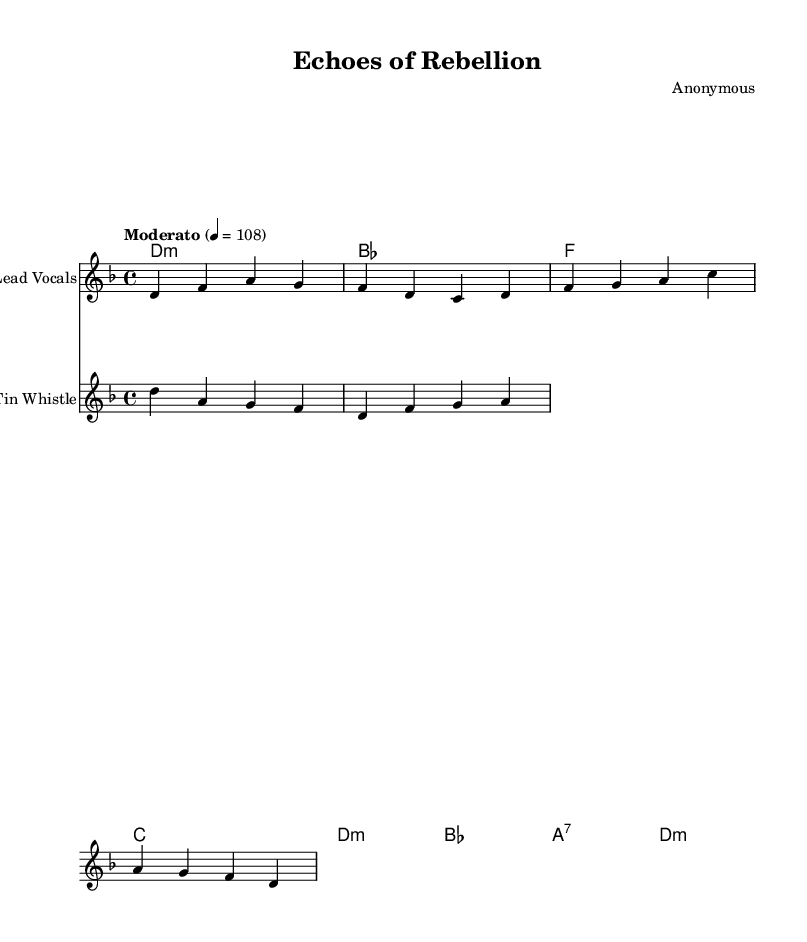What is the key signature of this music? The key signature is D minor, indicated by the presence of one flat (B flat) in the key signature.
Answer: D minor What is the time signature? The time signature is 4/4, which is commonly notated at the beginning of the sheet music.
Answer: 4/4 What is the tempo marking given? The tempo marking is "Moderato," indicating a moderate pace for the music.
Answer: Moderato How many chords are used in the harmonies? There are four distinct chords used in the harmonies: D minor, B flat, F major, and C major, plus a seventh chord in the sequence.
Answer: Four Identify the instrument associated with the second staff. The second staff is associated with the "Tin Whistle," which is indicated by the label provided in the staff description.
Answer: Tin Whistle What phrase is sung in the first verse? The phrase sung in the first verse includes "In the streets of Dublin town." This can be seen underneath the staff that represents the Lead Vocals.
Answer: In the streets of Dublin town What is the first note of the melody in the lead vocals? The first note of the melody in the lead vocals is D, which appears at the start of the melody line.
Answer: D 